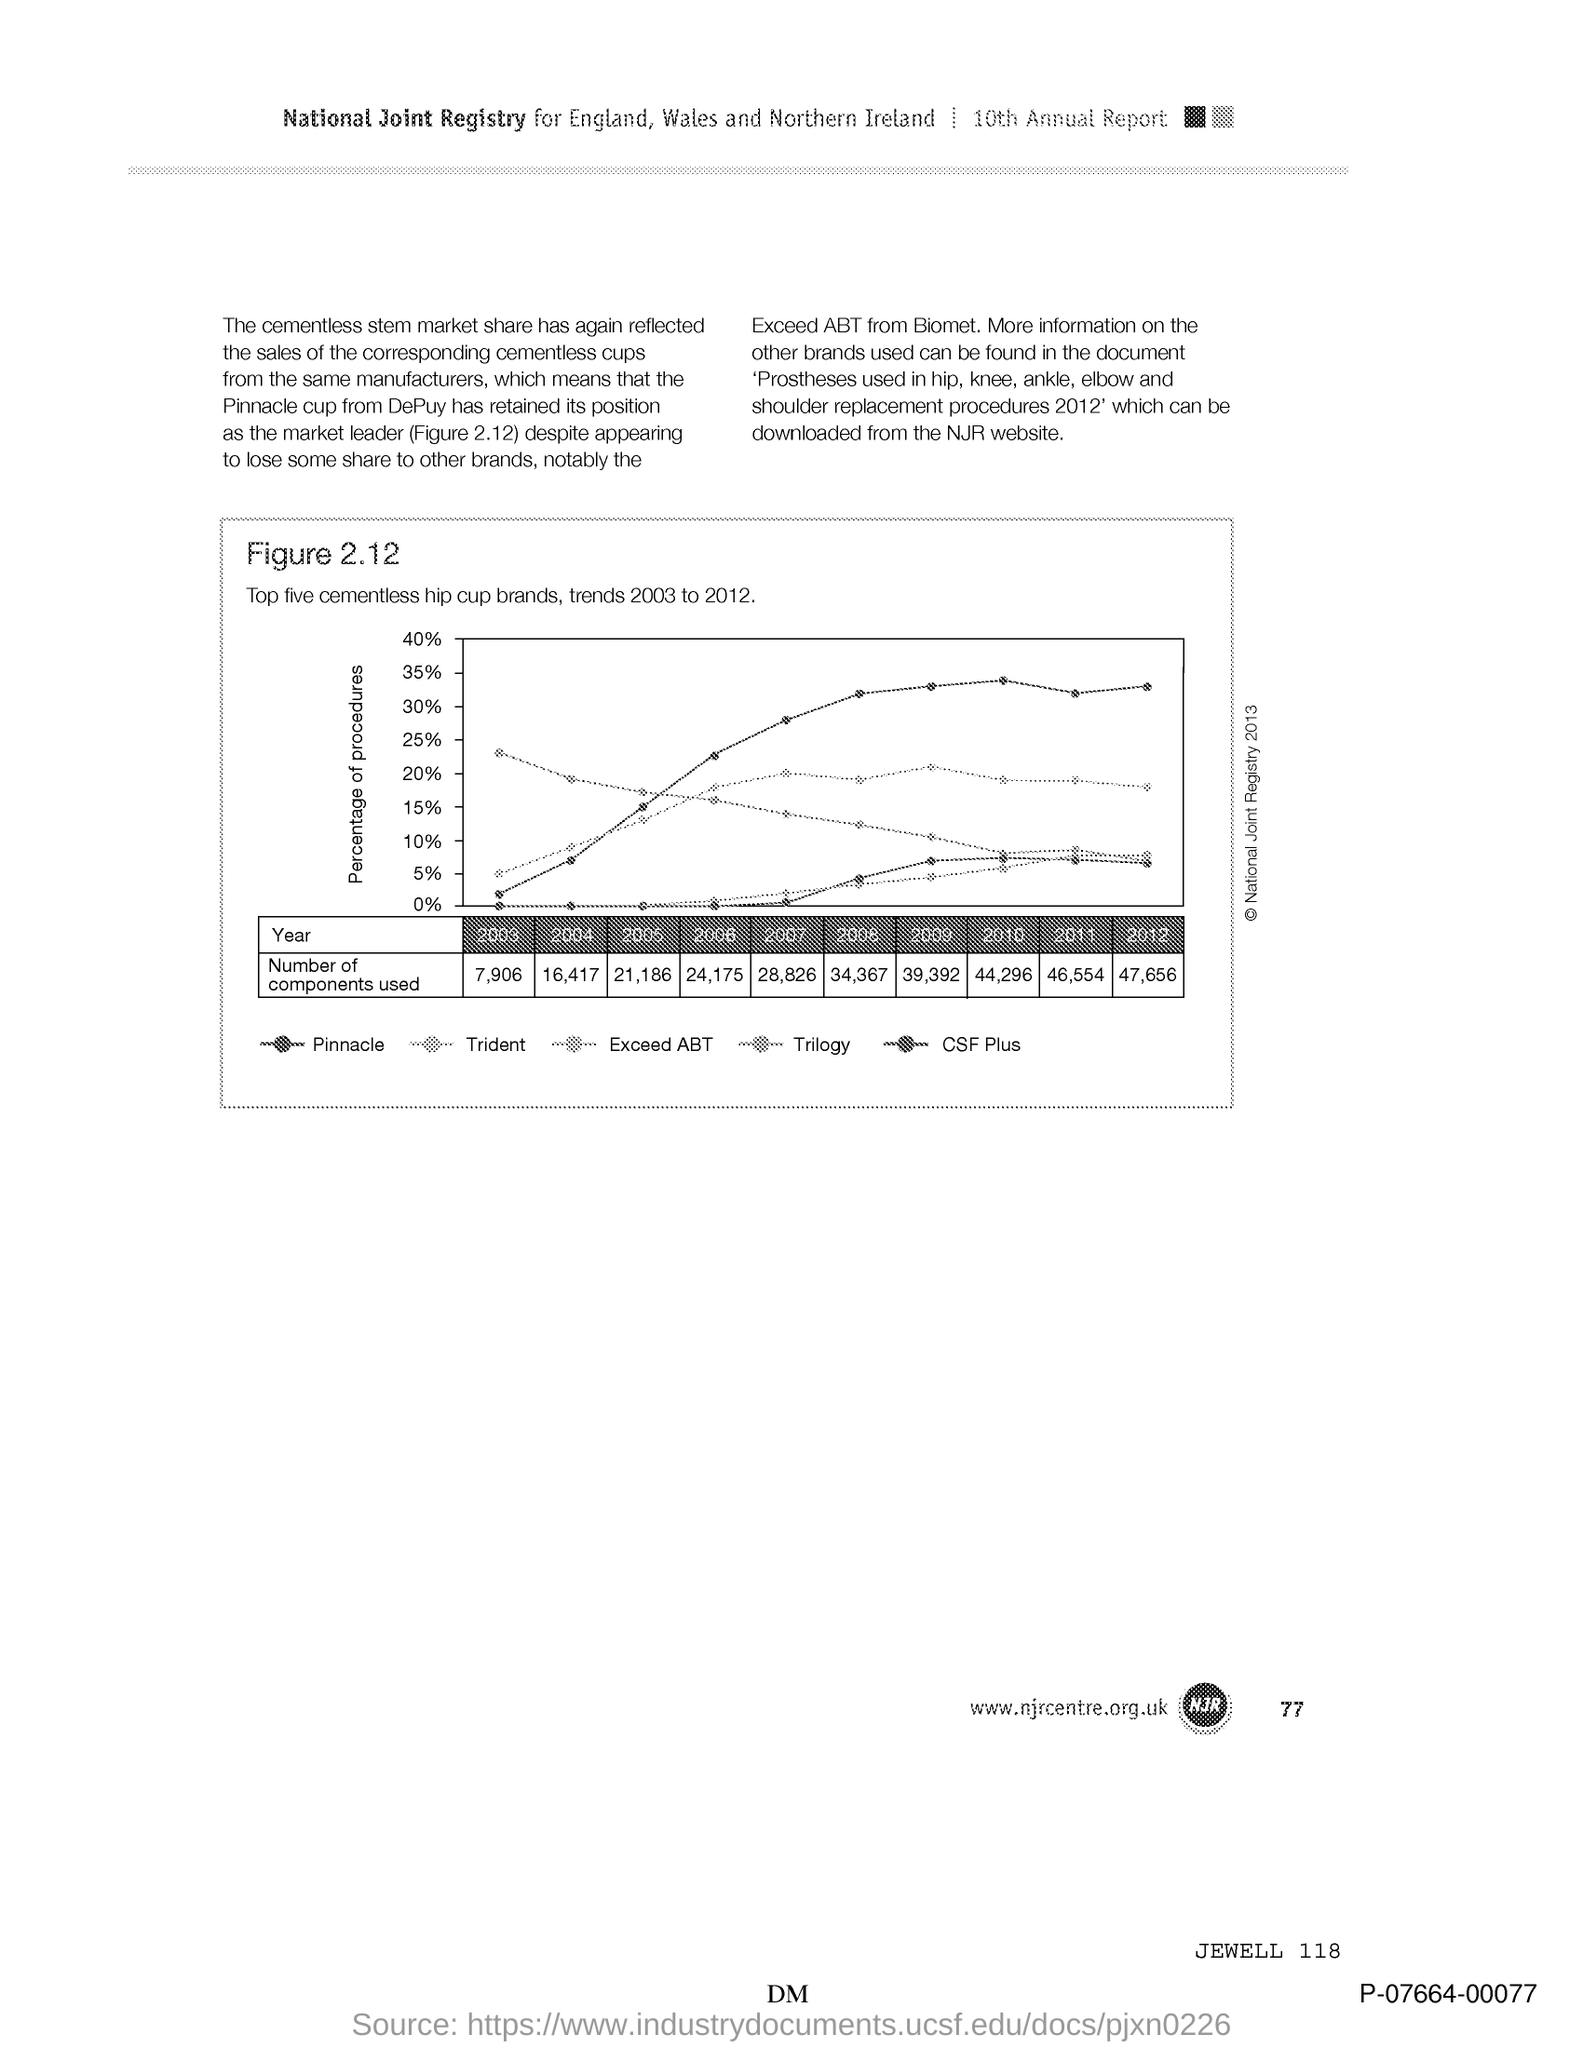What is the Page Number?
Offer a very short reply. 77. 